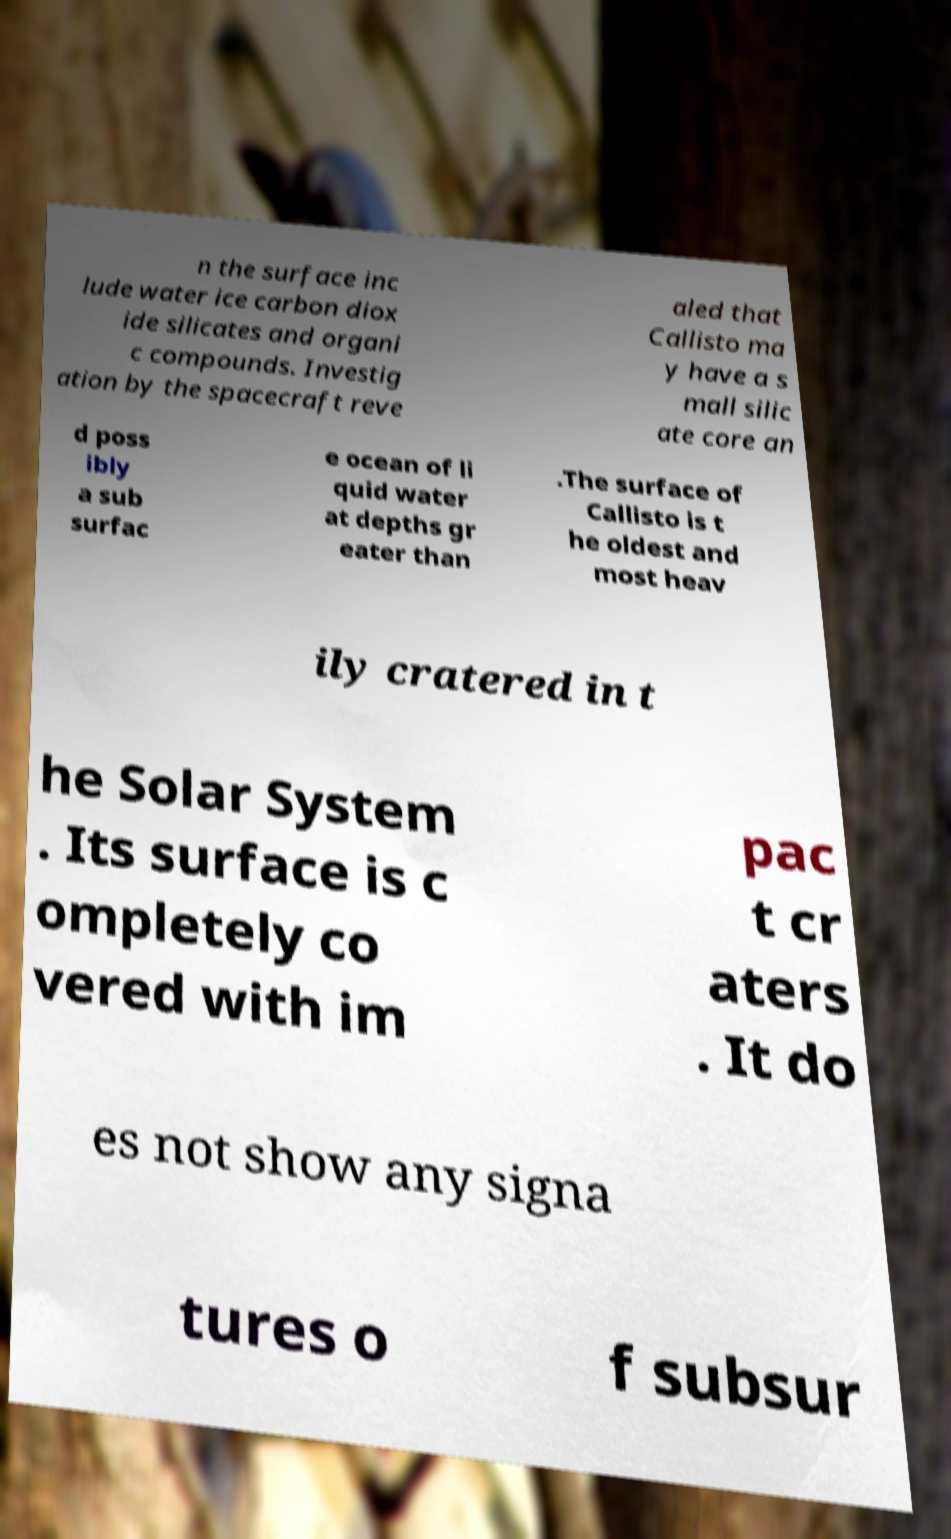What messages or text are displayed in this image? I need them in a readable, typed format. n the surface inc lude water ice carbon diox ide silicates and organi c compounds. Investig ation by the spacecraft reve aled that Callisto ma y have a s mall silic ate core an d poss ibly a sub surfac e ocean of li quid water at depths gr eater than .The surface of Callisto is t he oldest and most heav ily cratered in t he Solar System . Its surface is c ompletely co vered with im pac t cr aters . It do es not show any signa tures o f subsur 